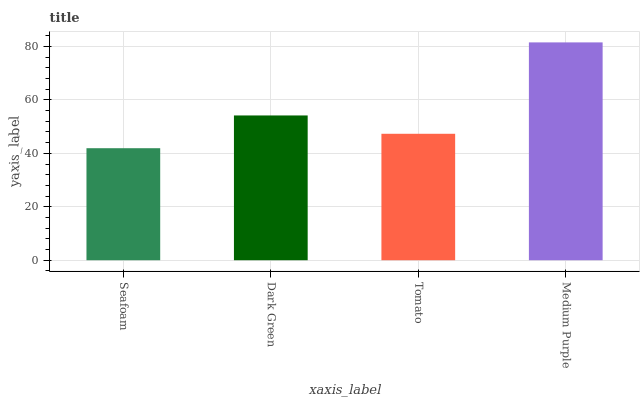Is Seafoam the minimum?
Answer yes or no. Yes. Is Medium Purple the maximum?
Answer yes or no. Yes. Is Dark Green the minimum?
Answer yes or no. No. Is Dark Green the maximum?
Answer yes or no. No. Is Dark Green greater than Seafoam?
Answer yes or no. Yes. Is Seafoam less than Dark Green?
Answer yes or no. Yes. Is Seafoam greater than Dark Green?
Answer yes or no. No. Is Dark Green less than Seafoam?
Answer yes or no. No. Is Dark Green the high median?
Answer yes or no. Yes. Is Tomato the low median?
Answer yes or no. Yes. Is Tomato the high median?
Answer yes or no. No. Is Seafoam the low median?
Answer yes or no. No. 